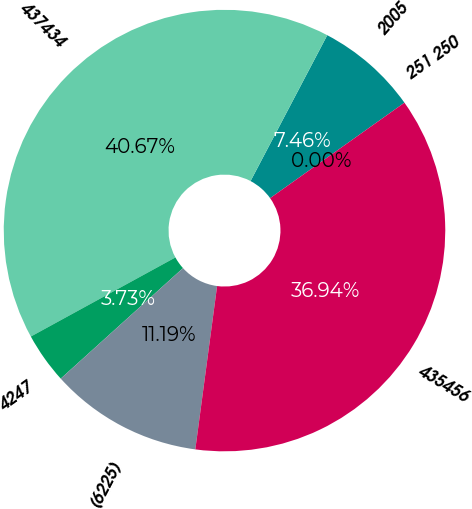Convert chart to OTSL. <chart><loc_0><loc_0><loc_500><loc_500><pie_chart><fcel>2005<fcel>437434<fcel>4247<fcel>(6225)<fcel>435456<fcel>251 250<nl><fcel>7.46%<fcel>40.67%<fcel>3.73%<fcel>11.19%<fcel>36.94%<fcel>0.0%<nl></chart> 